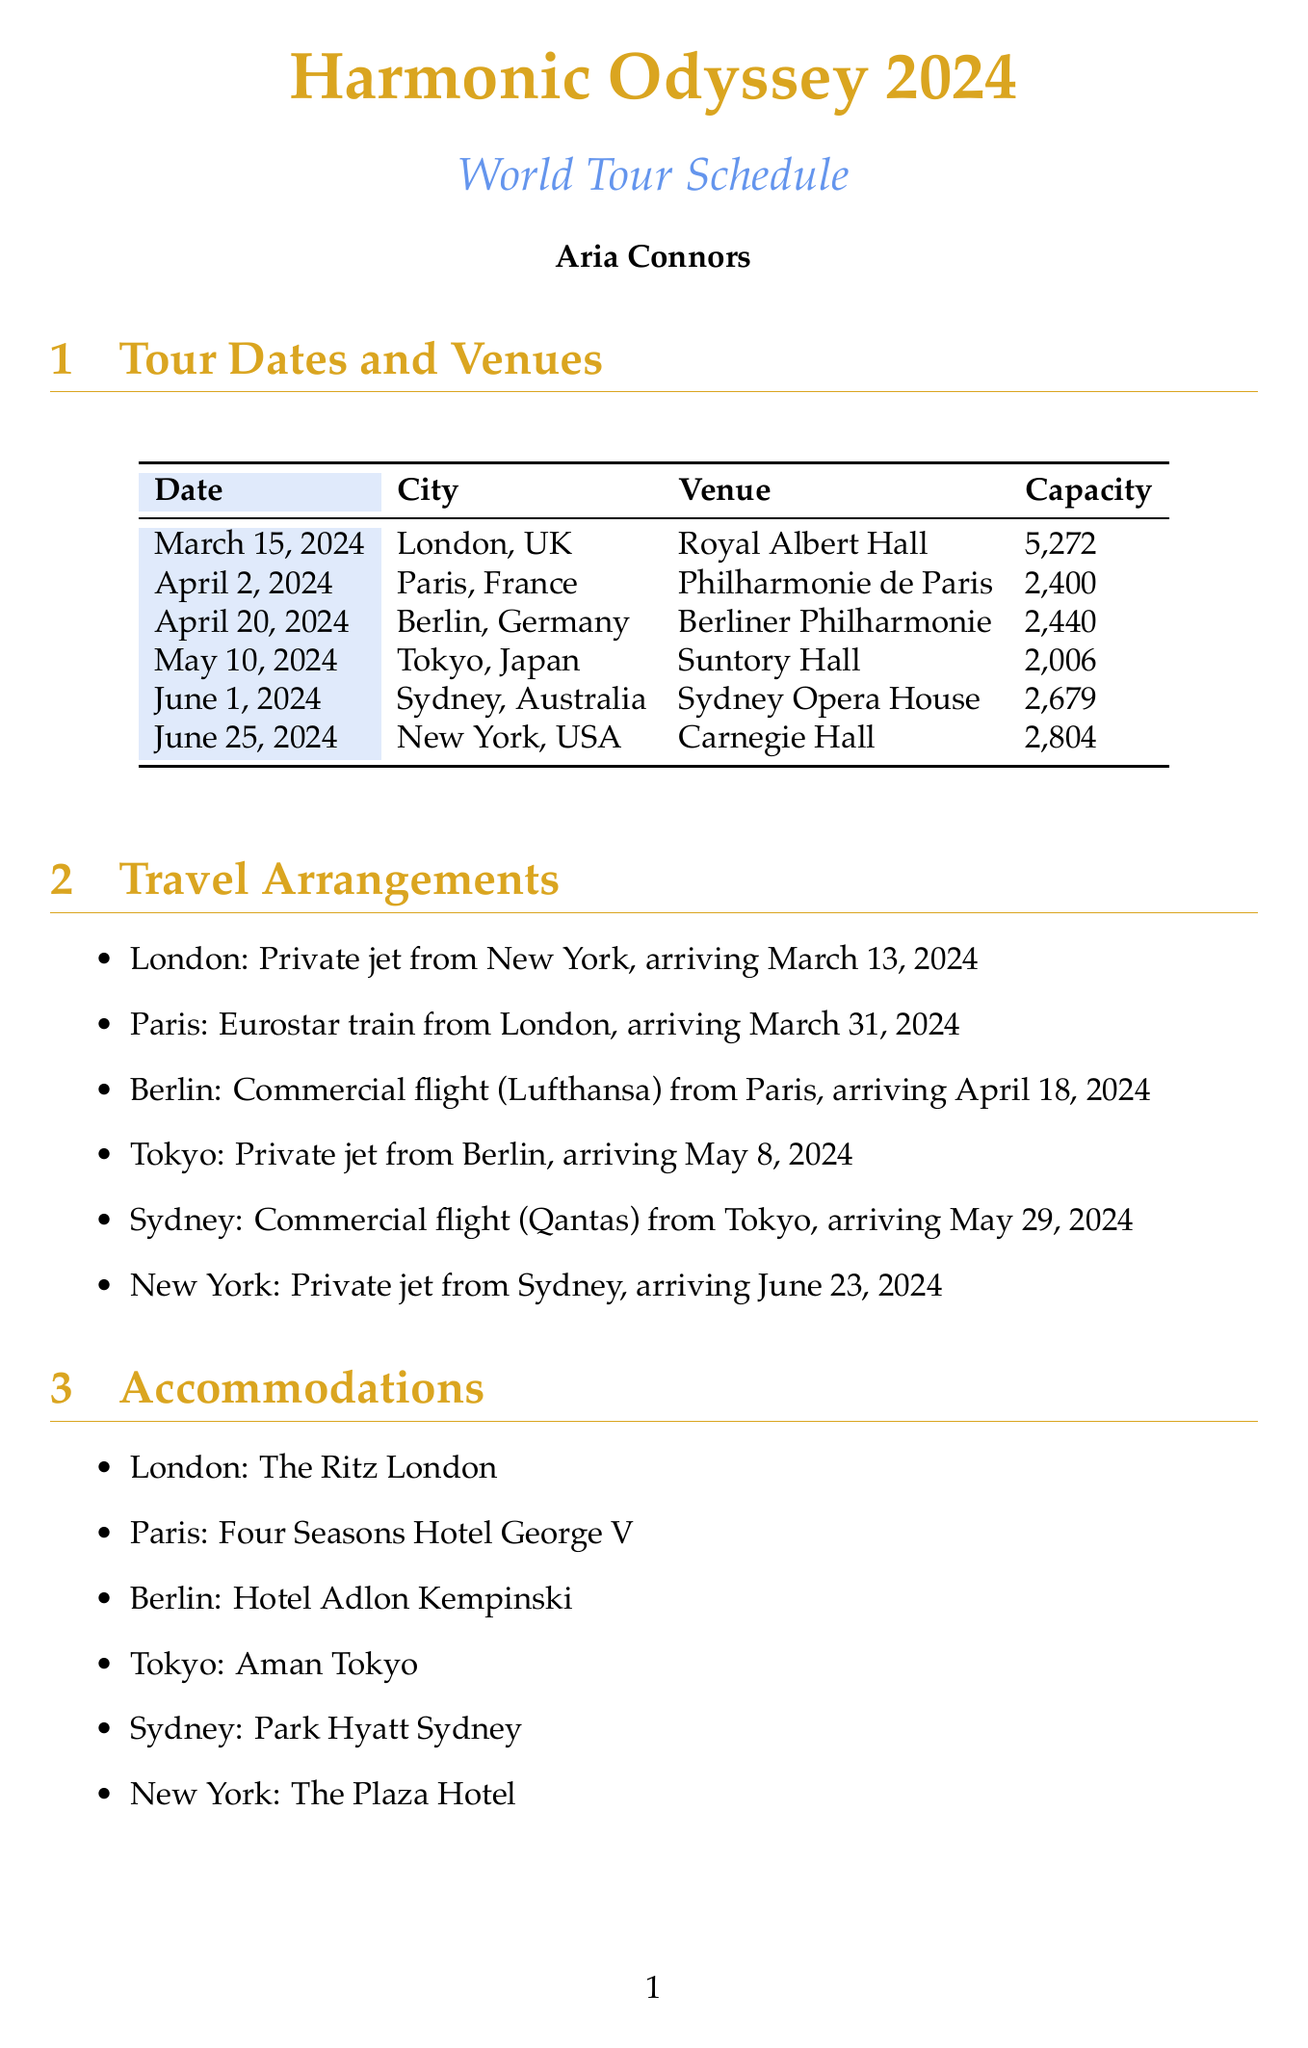what is the name of the tour? The name of the tour is specified in the document's title section.
Answer: Harmonic Odyssey 2024 who is the lead vocalist? The lead vocalist is mentioned in the tour personnel section.
Answer: Aria Connors what is the capacity of the Royal Albert Hall? The capacity is provided in the table of tour dates and venues.
Answer: 5,272 which city will the tour be in on April 20, 2024? The city for this date is listed in the tour dates section.
Answer: Berlin what type of transport will be used to travel from Berlin to Tokyo? The transport method is specified in the travel arrangements section.
Answer: Private jet how many team members are listed in the tour personnel? The total number of personnel is counted from the tour personnel table.
Answer: 8 what is the accommodation in Tokyo? The accommodation details are listed in the travel arrangements section.
Answer: Aman Tokyo which special consideration involves local musicians? The special considerations section outlines various needs, including this one.
Answer: Local string quartet to be hired for supporting act in each city when does the tour start? The start date of the tour can be found in the tour dates list.
Answer: March 15, 2024 